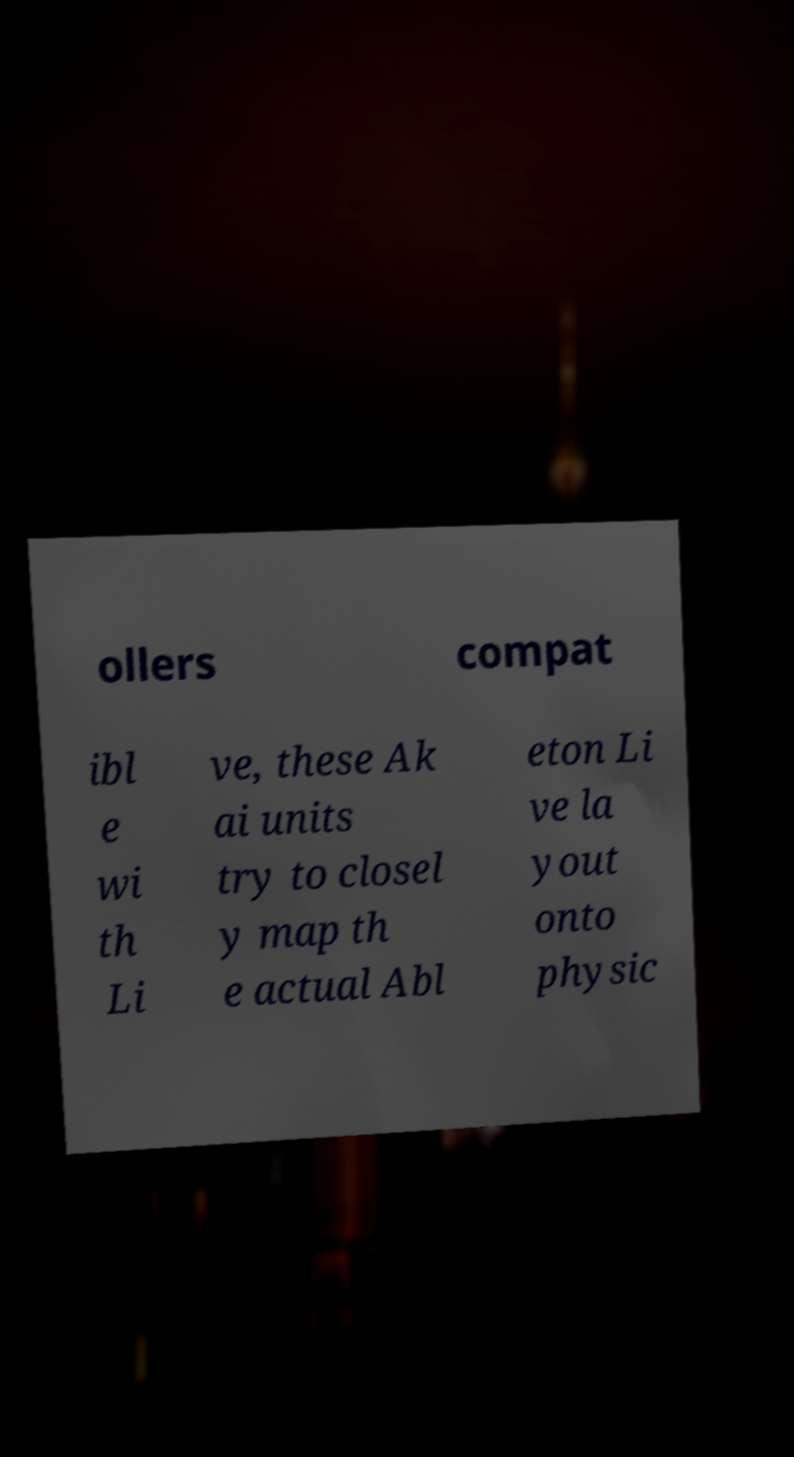Could you assist in decoding the text presented in this image and type it out clearly? ollers compat ibl e wi th Li ve, these Ak ai units try to closel y map th e actual Abl eton Li ve la yout onto physic 